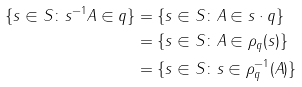<formula> <loc_0><loc_0><loc_500><loc_500>\{ s \in S \colon s ^ { - 1 } A \in q \} & = \{ s \in S \colon A \in s \cdot q \} \\ & = \{ s \in S \colon A \in \rho _ { q } ( s ) \} \\ & = \{ s \in S \colon s \in \rho _ { q } ^ { - 1 } ( A ) \} \\</formula> 